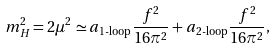<formula> <loc_0><loc_0><loc_500><loc_500>m ^ { 2 } _ { H } = 2 \mu ^ { 2 } \simeq a _ { { \text {1-loop} } } \frac { f ^ { 2 } } { 1 6 \pi ^ { 2 } } + a _ { { \text {2-loop} } } \frac { f ^ { 2 } } { 1 6 \pi ^ { 2 } } ,</formula> 